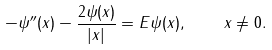Convert formula to latex. <formula><loc_0><loc_0><loc_500><loc_500>- \psi ^ { \prime \prime } ( x ) - \frac { 2 \psi ( x ) } { | x | } = E \psi ( x ) , \quad x \neq 0 .</formula> 